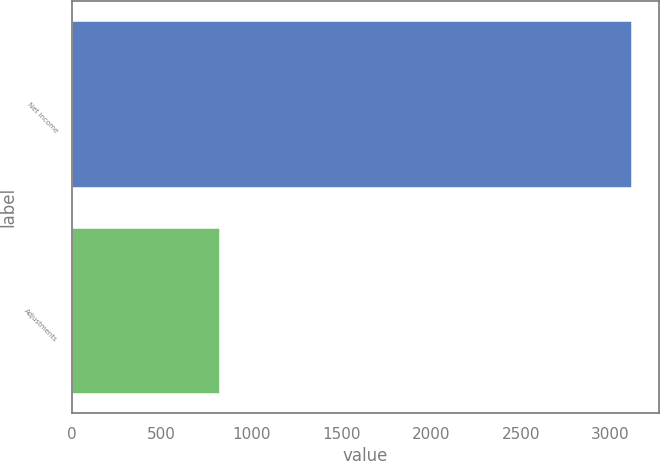Convert chart. <chart><loc_0><loc_0><loc_500><loc_500><bar_chart><fcel>Net income<fcel>Adjustments<nl><fcel>3116<fcel>818<nl></chart> 